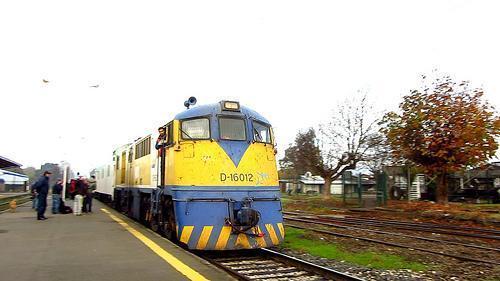How many trains are there?
Give a very brief answer. 1. 